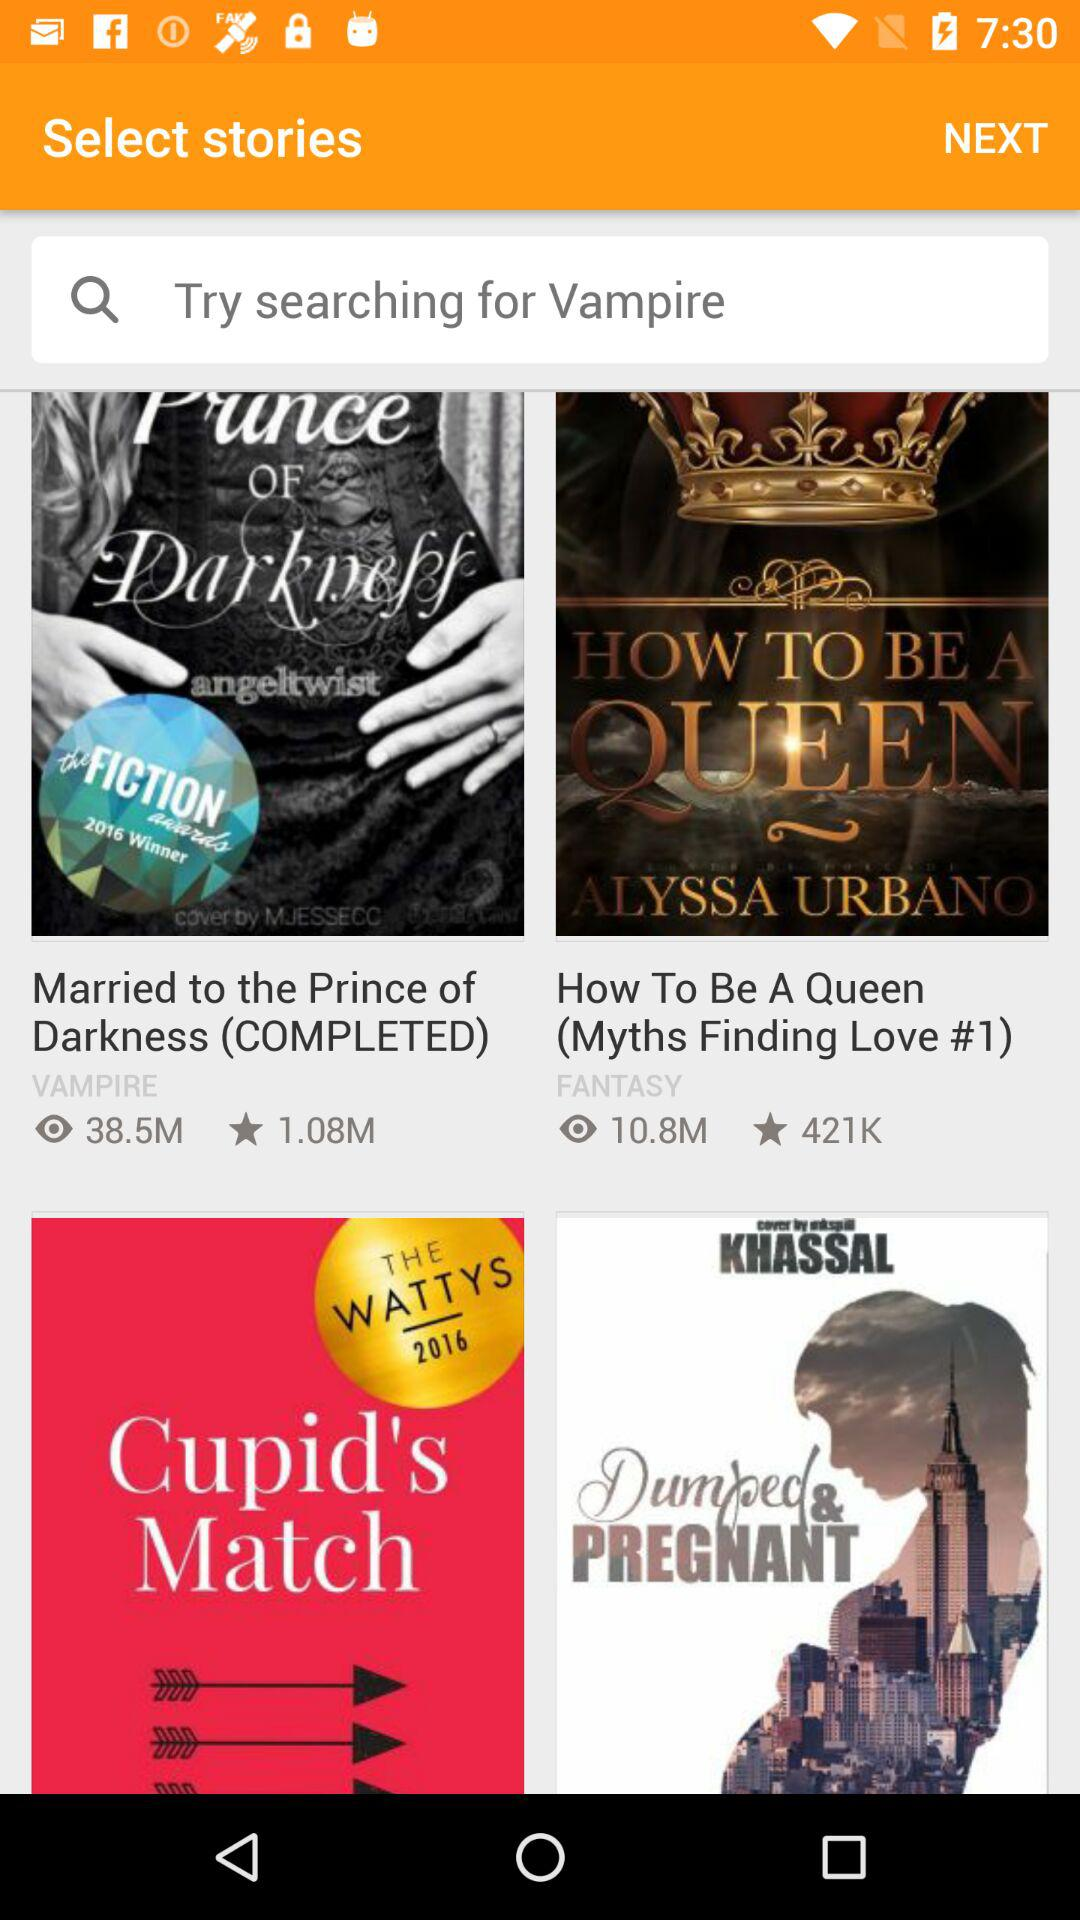What's the number of views of the "How To Be A Queen" book? The number of views is 10.8 million. 